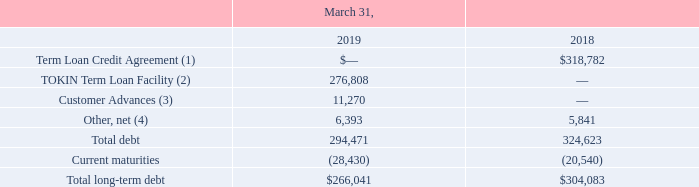Note 3: Debt
A summary of debt is as follows (amounts in thousands):
(1) Amount shown is net of discount, bank issuance costs and other indirect issuance costs of $13.3 million as of March 31, 2018.
(2) Amount shown is net of discount, bank issuance costs and other indirect issuance costs of $8.7 million as of March 31, 2019.
(3) Amount shown is net of discount of $2.1 million as of March 31, 2019.
(4) Amounts shown are net of discounts of $0.6 million and $0.5 million as of March 31, 2019 and 2018, respectively.
What was the amount of discount for Customer Advances?
Answer scale should be: million. 2.1. What was the Term Loan Credit Agreement  in 2018?
Answer scale should be: thousand. 318,782. Which years does the table provide information for the company's summary of debt? 2019, 2018. What was the change in Total debt between 2018 and 2019?
Answer scale should be: thousand. 294,471-324,623
Answer: -30152. What was the change in current maturities between 2018 and 2019?
Answer scale should be: thousand. -28,430-(-20,540)
Answer: -7890. What was the percentage change in total long-term debt between 2018 and 2019?
Answer scale should be: percent. (266,041-304,083)/304,083
Answer: -12.51. 